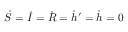Convert formula to latex. <formula><loc_0><loc_0><loc_500><loc_500>\dot { S } = \dot { I } = \dot { R } = \dot { h } ^ { \prime } = \dot { h } = 0</formula> 